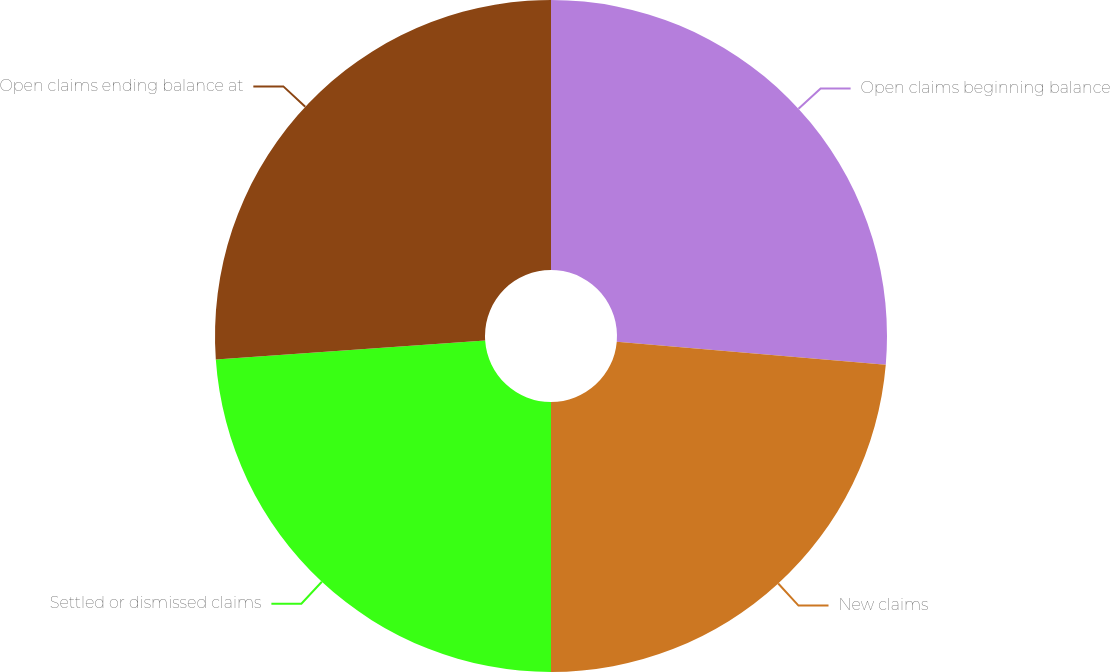Convert chart. <chart><loc_0><loc_0><loc_500><loc_500><pie_chart><fcel>Open claims beginning balance<fcel>New claims<fcel>Settled or dismissed claims<fcel>Open claims ending balance at<nl><fcel>26.36%<fcel>23.64%<fcel>23.89%<fcel>26.11%<nl></chart> 